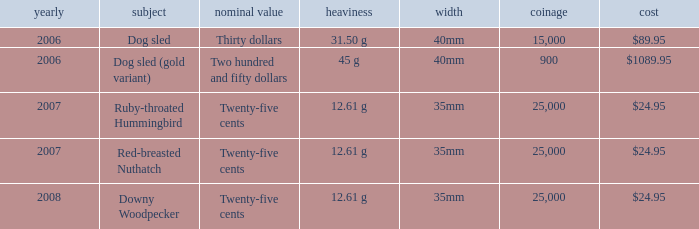What is the Diameter of the Dog Sled (gold variant) Theme coin? 40mm. 